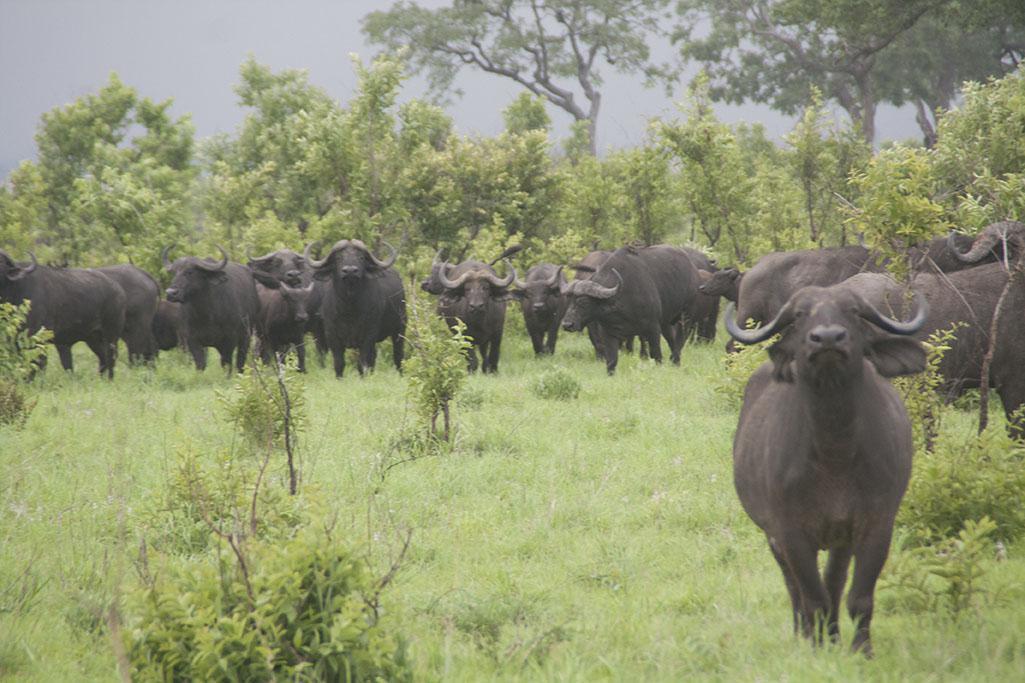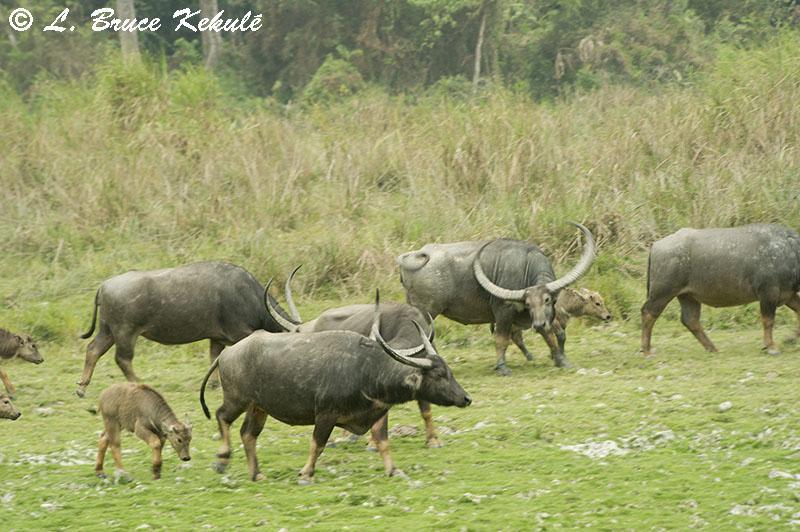The first image is the image on the left, the second image is the image on the right. Examine the images to the left and right. Is the description "water buffalo are at the water hole" accurate? Answer yes or no. No. The first image is the image on the left, the second image is the image on the right. Given the left and right images, does the statement "There are no more than six water buffaloes in the left image." hold true? Answer yes or no. No. 